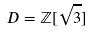<formula> <loc_0><loc_0><loc_500><loc_500>D = \mathbb { Z } [ \sqrt { 3 } ]</formula> 